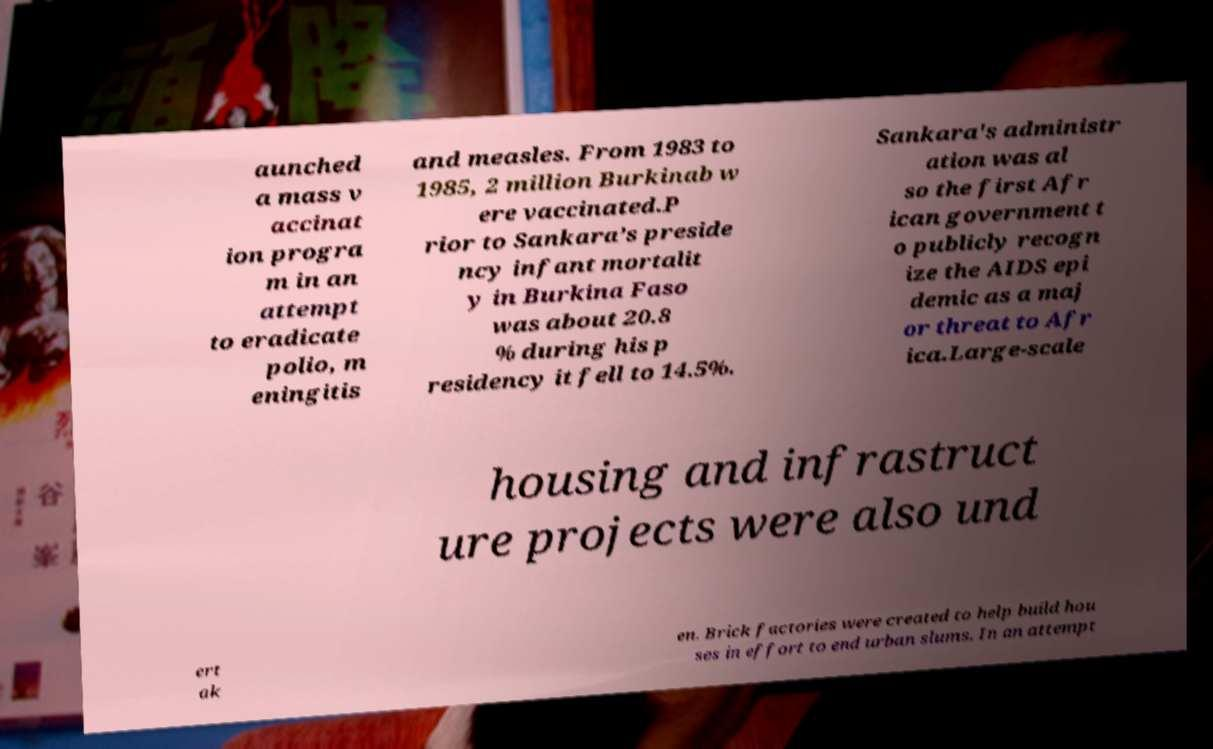Can you accurately transcribe the text from the provided image for me? aunched a mass v accinat ion progra m in an attempt to eradicate polio, m eningitis and measles. From 1983 to 1985, 2 million Burkinab w ere vaccinated.P rior to Sankara’s preside ncy infant mortalit y in Burkina Faso was about 20.8 % during his p residency it fell to 14.5%. Sankara's administr ation was al so the first Afr ican government t o publicly recogn ize the AIDS epi demic as a maj or threat to Afr ica.Large-scale housing and infrastruct ure projects were also und ert ak en. Brick factories were created to help build hou ses in effort to end urban slums. In an attempt 